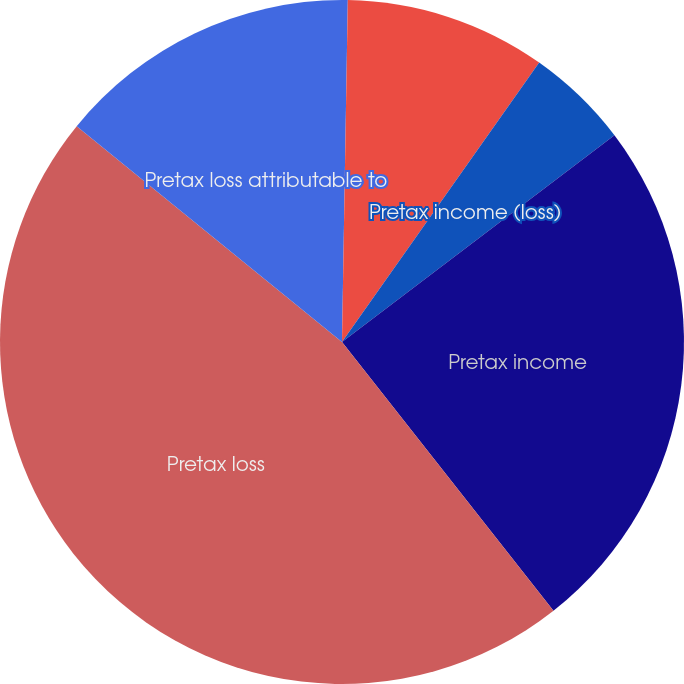Convert chart to OTSL. <chart><loc_0><loc_0><loc_500><loc_500><pie_chart><fcel>Net revenues<fcel>Expenses<fcel>Pretax income (loss)<fcel>Pretax income<fcel>Pretax loss<fcel>Pretax loss attributable to<nl><fcel>0.27%<fcel>9.51%<fcel>4.89%<fcel>24.72%<fcel>46.48%<fcel>14.13%<nl></chart> 